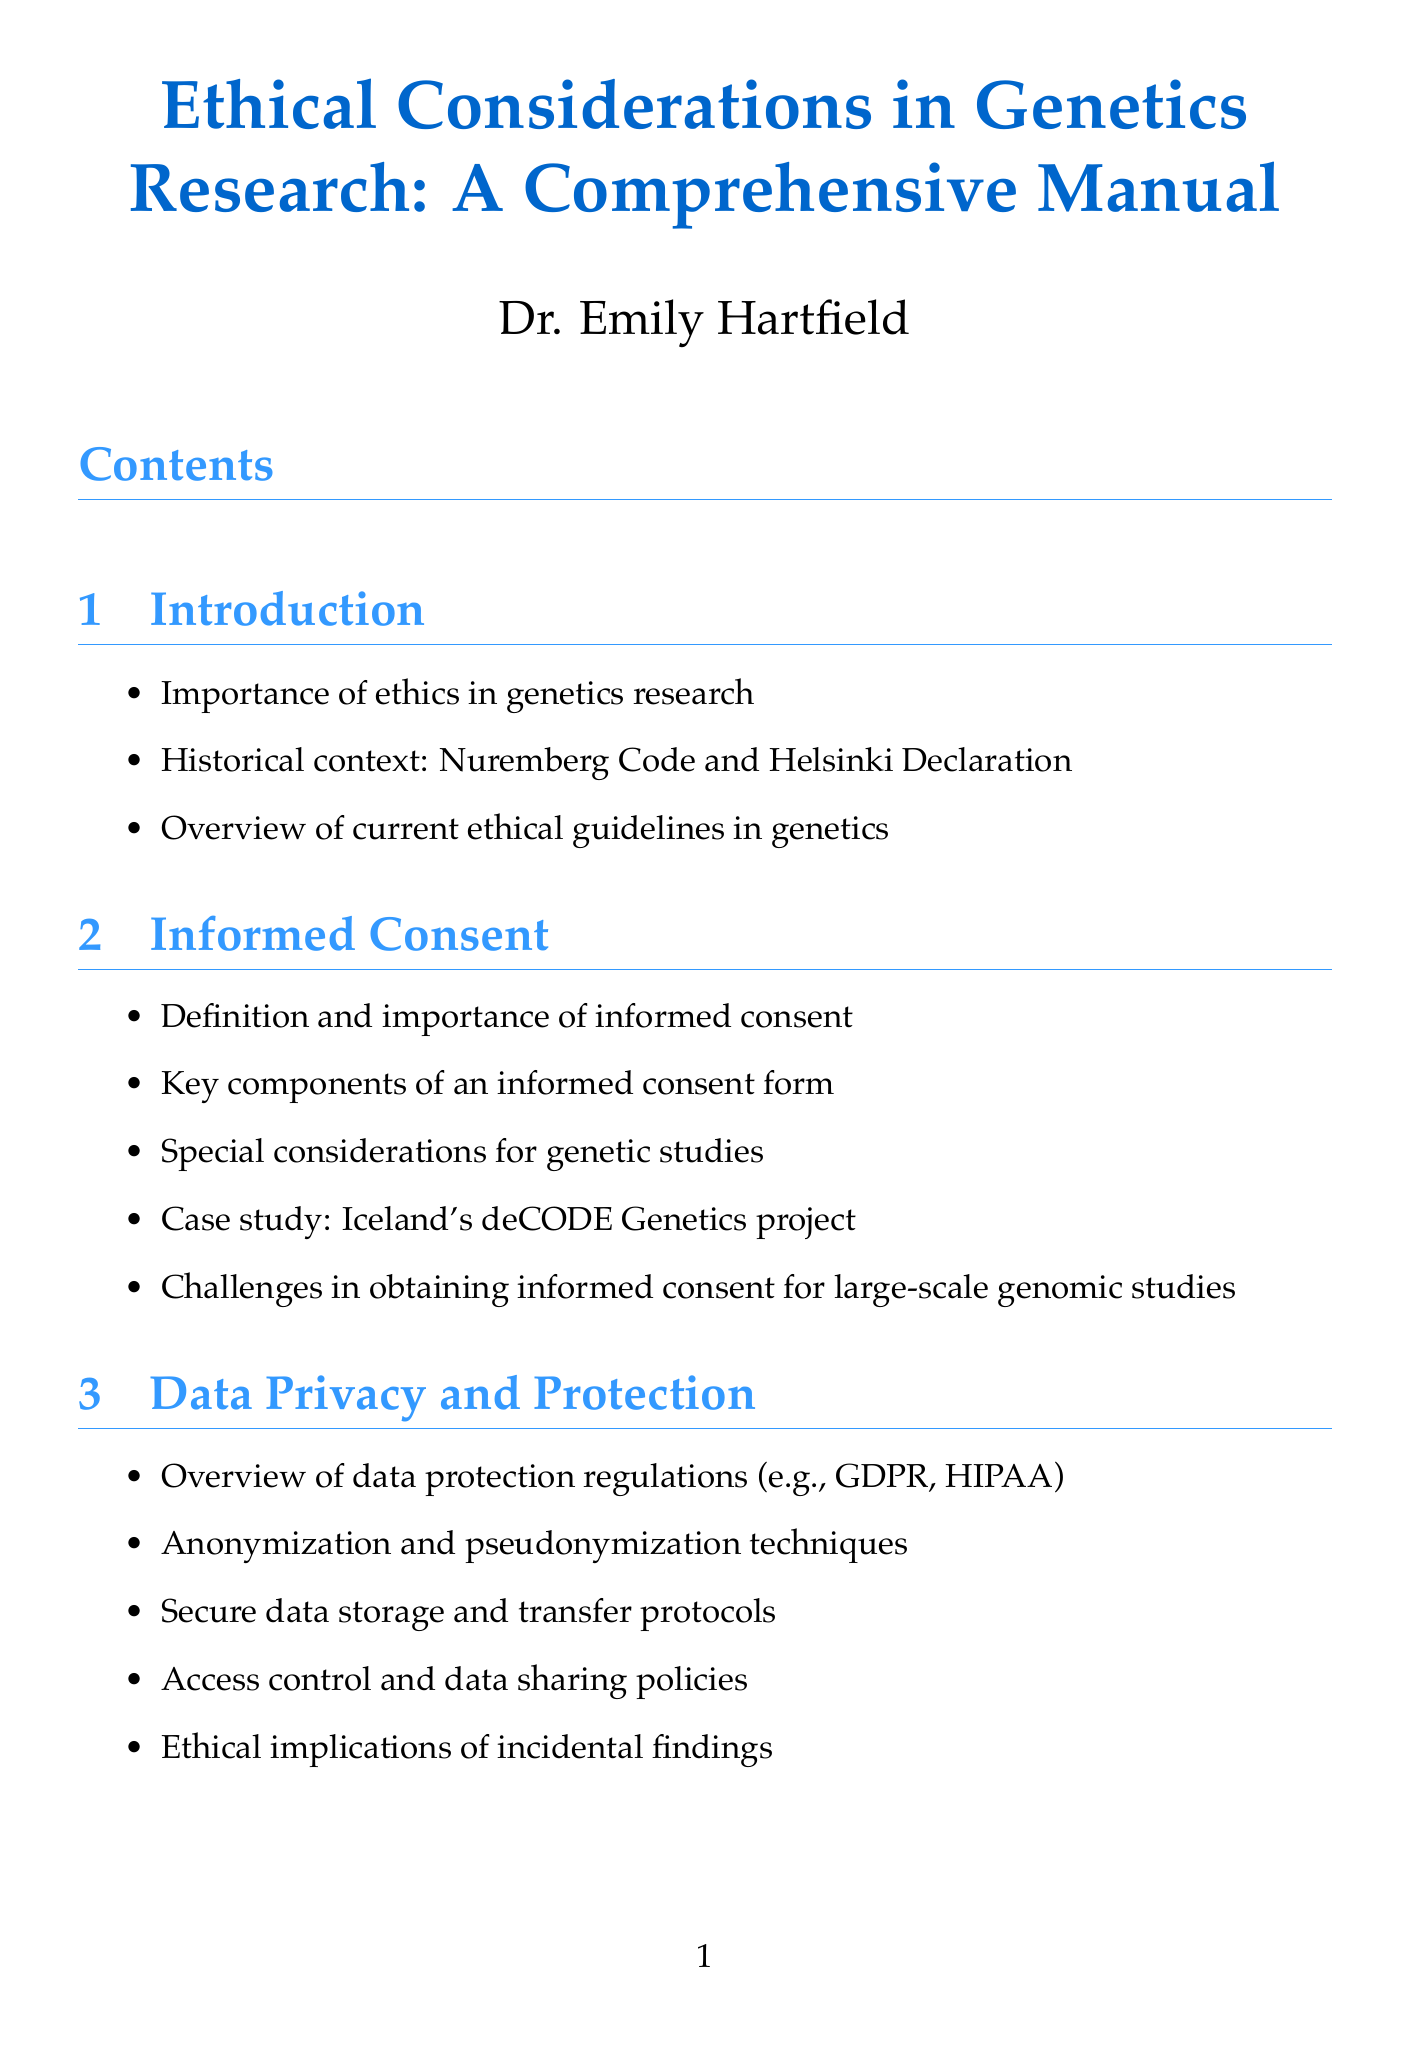What is the title of the manual? The title of the manual is stated prominently at the beginning of the document.
Answer: Ethical Considerations in Genetics Research: A Comprehensive Manual Who is the author of the manual? The author is mentioned under the title section of the document.
Answer: Dr. Emily Hartfield What is one key component of informed consent? The document lists components in the section discussing informed consent.
Answer: Key components of an informed consent form What legal protections are mentioned in the section on genetic discrimination? The document specifies legal protections in the relevant section.
Answer: Genetic Information Nondiscrimination Act (GINA) What is a case study mentioned in the contextualized discussion of informed consent? The manual provides a specific case study to illustrate informed consent issues.
Answer: Iceland's deCODE Genetics project How many sections are in the manual? The total number of sections is indicated in the table of contents of the document.
Answer: Ten What ethical issue is discussed regarding genetic testing in children? The content lists various considerations in the section on genetic testing, focusing on children.
Answer: Ethical dilemmas in disclosing genetic test results Which organization is listed under the resources section? The document includes a list of organizations related to genetics research in the resources section.
Answer: National Human Genome Research Institute (NHGRI) What online course is provided in the resources section? The manual includes options for online courses, which are identified in the resources part.
Answer: Genomics: Ethical, Legal, and Social Implications What does the conclusion of the manual emphasize? The conclusion discusses overarching themes about ethics in genetics research.
Answer: Importance of ongoing dialogue and education in research ethics 